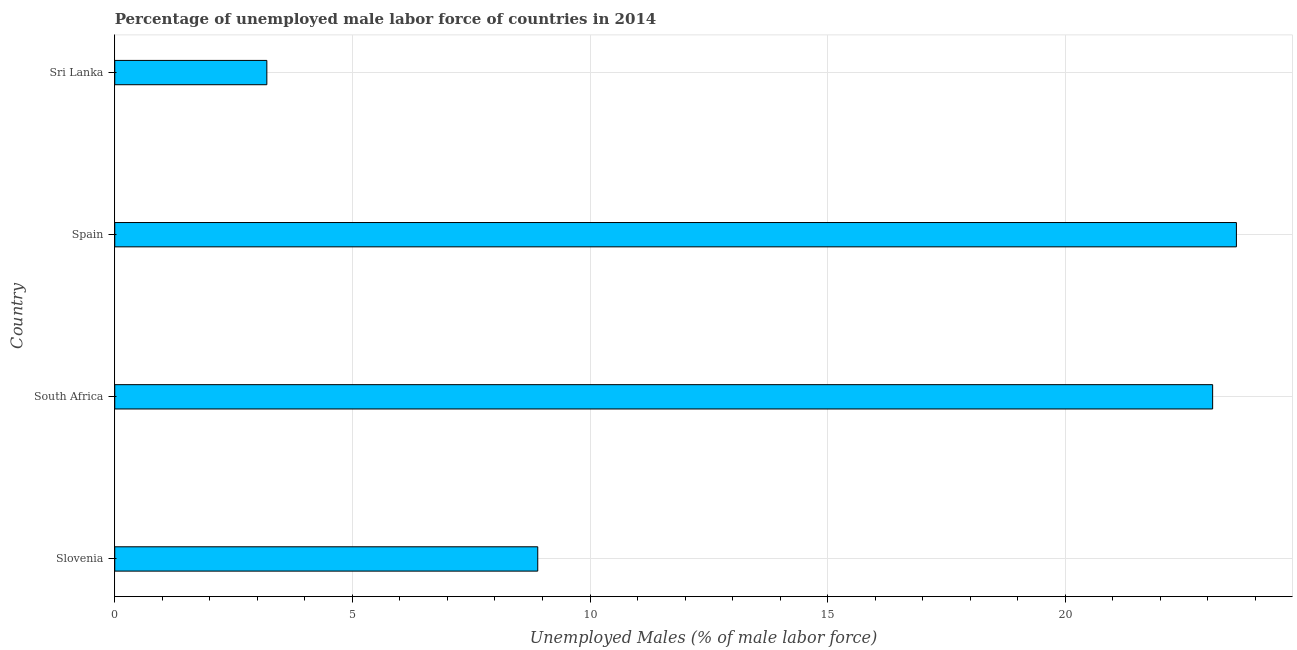Does the graph contain any zero values?
Ensure brevity in your answer.  No. Does the graph contain grids?
Your response must be concise. Yes. What is the title of the graph?
Offer a terse response. Percentage of unemployed male labor force of countries in 2014. What is the label or title of the X-axis?
Give a very brief answer. Unemployed Males (% of male labor force). What is the label or title of the Y-axis?
Offer a very short reply. Country. What is the total unemployed male labour force in Spain?
Keep it short and to the point. 23.6. Across all countries, what is the maximum total unemployed male labour force?
Ensure brevity in your answer.  23.6. Across all countries, what is the minimum total unemployed male labour force?
Offer a very short reply. 3.2. In which country was the total unemployed male labour force maximum?
Offer a very short reply. Spain. In which country was the total unemployed male labour force minimum?
Your answer should be very brief. Sri Lanka. What is the sum of the total unemployed male labour force?
Your answer should be very brief. 58.8. What is the difference between the total unemployed male labour force in Slovenia and Spain?
Your answer should be compact. -14.7. What is the average total unemployed male labour force per country?
Your response must be concise. 14.7. What is the median total unemployed male labour force?
Provide a short and direct response. 16. What is the ratio of the total unemployed male labour force in Slovenia to that in Spain?
Offer a terse response. 0.38. Is the total unemployed male labour force in South Africa less than that in Spain?
Your response must be concise. Yes. Is the sum of the total unemployed male labour force in South Africa and Spain greater than the maximum total unemployed male labour force across all countries?
Your answer should be compact. Yes. What is the difference between the highest and the lowest total unemployed male labour force?
Provide a short and direct response. 20.4. In how many countries, is the total unemployed male labour force greater than the average total unemployed male labour force taken over all countries?
Offer a very short reply. 2. Are all the bars in the graph horizontal?
Your answer should be compact. Yes. What is the difference between two consecutive major ticks on the X-axis?
Make the answer very short. 5. What is the Unemployed Males (% of male labor force) of Slovenia?
Your answer should be very brief. 8.9. What is the Unemployed Males (% of male labor force) of South Africa?
Your answer should be compact. 23.1. What is the Unemployed Males (% of male labor force) in Spain?
Your answer should be compact. 23.6. What is the Unemployed Males (% of male labor force) of Sri Lanka?
Your answer should be compact. 3.2. What is the difference between the Unemployed Males (% of male labor force) in Slovenia and South Africa?
Ensure brevity in your answer.  -14.2. What is the difference between the Unemployed Males (% of male labor force) in Slovenia and Spain?
Offer a very short reply. -14.7. What is the difference between the Unemployed Males (% of male labor force) in Slovenia and Sri Lanka?
Provide a succinct answer. 5.7. What is the difference between the Unemployed Males (% of male labor force) in South Africa and Spain?
Your answer should be compact. -0.5. What is the difference between the Unemployed Males (% of male labor force) in South Africa and Sri Lanka?
Ensure brevity in your answer.  19.9. What is the difference between the Unemployed Males (% of male labor force) in Spain and Sri Lanka?
Ensure brevity in your answer.  20.4. What is the ratio of the Unemployed Males (% of male labor force) in Slovenia to that in South Africa?
Offer a terse response. 0.39. What is the ratio of the Unemployed Males (% of male labor force) in Slovenia to that in Spain?
Offer a terse response. 0.38. What is the ratio of the Unemployed Males (% of male labor force) in Slovenia to that in Sri Lanka?
Provide a succinct answer. 2.78. What is the ratio of the Unemployed Males (% of male labor force) in South Africa to that in Spain?
Provide a short and direct response. 0.98. What is the ratio of the Unemployed Males (% of male labor force) in South Africa to that in Sri Lanka?
Offer a terse response. 7.22. What is the ratio of the Unemployed Males (% of male labor force) in Spain to that in Sri Lanka?
Provide a short and direct response. 7.38. 